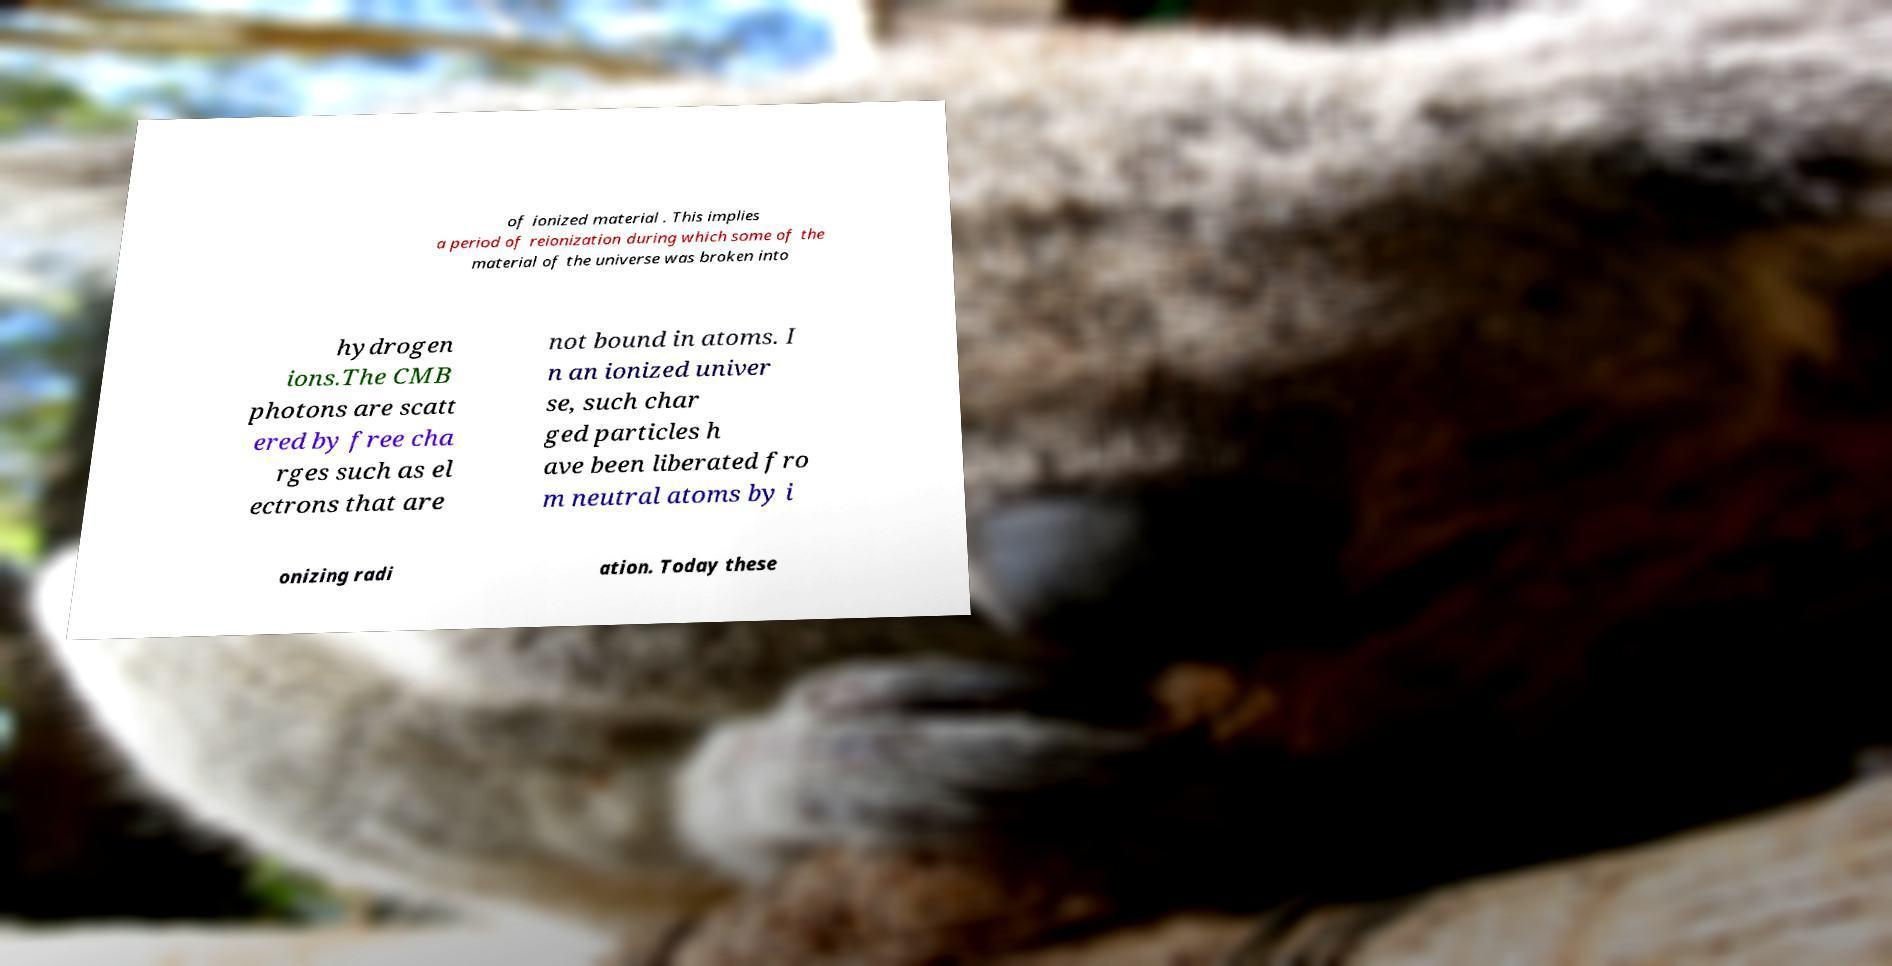Could you extract and type out the text from this image? of ionized material . This implies a period of reionization during which some of the material of the universe was broken into hydrogen ions.The CMB photons are scatt ered by free cha rges such as el ectrons that are not bound in atoms. I n an ionized univer se, such char ged particles h ave been liberated fro m neutral atoms by i onizing radi ation. Today these 